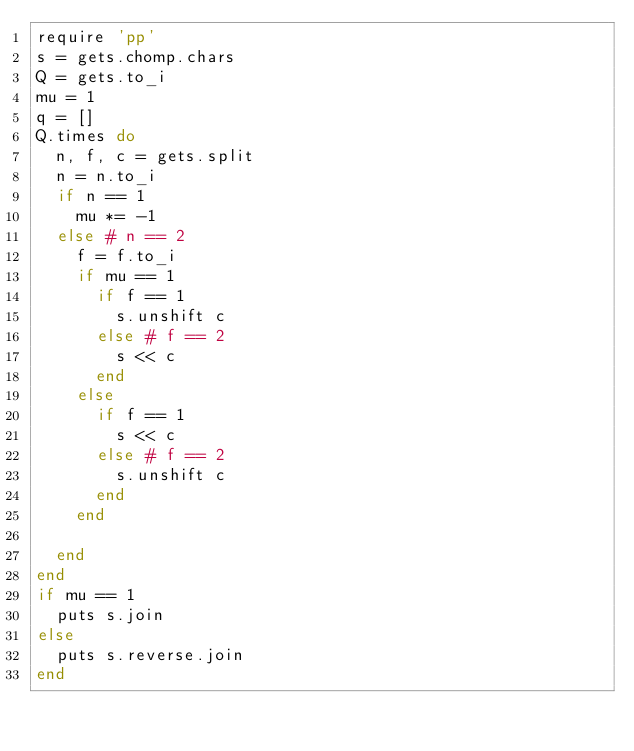Convert code to text. <code><loc_0><loc_0><loc_500><loc_500><_Ruby_>require 'pp'
s = gets.chomp.chars
Q = gets.to_i
mu = 1
q = []
Q.times do
  n, f, c = gets.split
  n = n.to_i
  if n == 1
    mu *= -1
  else # n == 2
    f = f.to_i
    if mu == 1
      if f == 1
        s.unshift c
      else # f == 2
        s << c
      end
    else
      if f == 1
        s << c
      else # f == 2
        s.unshift c
      end
    end

  end
end
if mu == 1
  puts s.join
else
  puts s.reverse.join
end

</code> 